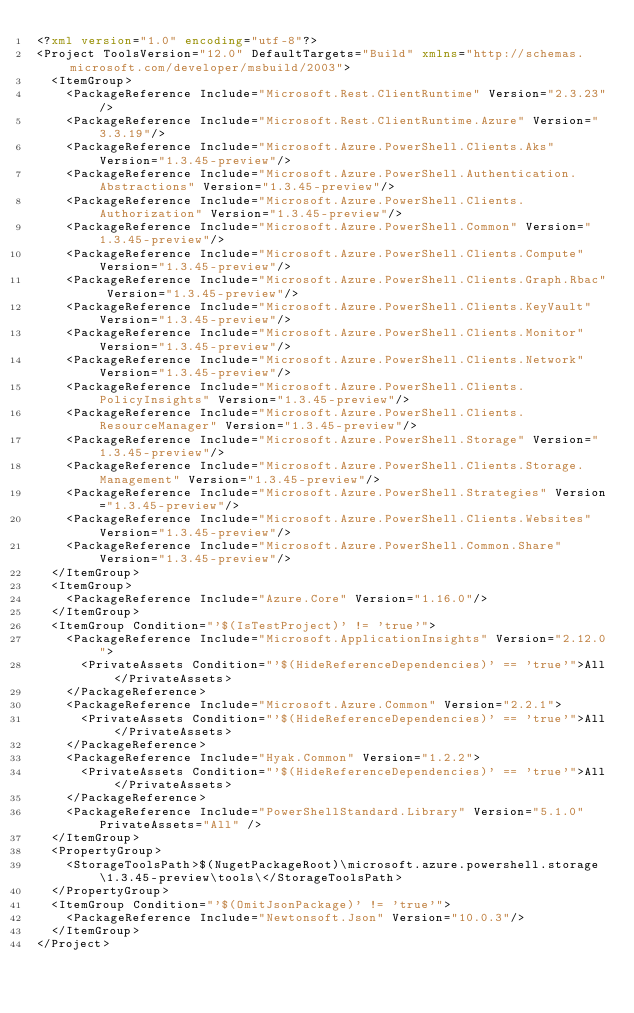Convert code to text. <code><loc_0><loc_0><loc_500><loc_500><_XML_><?xml version="1.0" encoding="utf-8"?>
<Project ToolsVersion="12.0" DefaultTargets="Build" xmlns="http://schemas.microsoft.com/developer/msbuild/2003">
  <ItemGroup>
    <PackageReference Include="Microsoft.Rest.ClientRuntime" Version="2.3.23"/>
    <PackageReference Include="Microsoft.Rest.ClientRuntime.Azure" Version="3.3.19"/>
    <PackageReference Include="Microsoft.Azure.PowerShell.Clients.Aks" Version="1.3.45-preview"/>
    <PackageReference Include="Microsoft.Azure.PowerShell.Authentication.Abstractions" Version="1.3.45-preview"/>
    <PackageReference Include="Microsoft.Azure.PowerShell.Clients.Authorization" Version="1.3.45-preview"/>
    <PackageReference Include="Microsoft.Azure.PowerShell.Common" Version="1.3.45-preview"/>
    <PackageReference Include="Microsoft.Azure.PowerShell.Clients.Compute" Version="1.3.45-preview"/>
    <PackageReference Include="Microsoft.Azure.PowerShell.Clients.Graph.Rbac" Version="1.3.45-preview"/>
    <PackageReference Include="Microsoft.Azure.PowerShell.Clients.KeyVault" Version="1.3.45-preview"/>
    <PackageReference Include="Microsoft.Azure.PowerShell.Clients.Monitor" Version="1.3.45-preview"/>
    <PackageReference Include="Microsoft.Azure.PowerShell.Clients.Network" Version="1.3.45-preview"/>
    <PackageReference Include="Microsoft.Azure.PowerShell.Clients.PolicyInsights" Version="1.3.45-preview"/>
    <PackageReference Include="Microsoft.Azure.PowerShell.Clients.ResourceManager" Version="1.3.45-preview"/>
    <PackageReference Include="Microsoft.Azure.PowerShell.Storage" Version="1.3.45-preview"/>
    <PackageReference Include="Microsoft.Azure.PowerShell.Clients.Storage.Management" Version="1.3.45-preview"/>
    <PackageReference Include="Microsoft.Azure.PowerShell.Strategies" Version="1.3.45-preview"/>
    <PackageReference Include="Microsoft.Azure.PowerShell.Clients.Websites" Version="1.3.45-preview"/>
    <PackageReference Include="Microsoft.Azure.PowerShell.Common.Share" Version="1.3.45-preview"/>
  </ItemGroup>
  <ItemGroup>
    <PackageReference Include="Azure.Core" Version="1.16.0"/>
  </ItemGroup>
  <ItemGroup Condition="'$(IsTestProject)' != 'true'">
    <PackageReference Include="Microsoft.ApplicationInsights" Version="2.12.0">
      <PrivateAssets Condition="'$(HideReferenceDependencies)' == 'true'">All</PrivateAssets>
    </PackageReference>
    <PackageReference Include="Microsoft.Azure.Common" Version="2.2.1">
      <PrivateAssets Condition="'$(HideReferenceDependencies)' == 'true'">All</PrivateAssets>
    </PackageReference>
    <PackageReference Include="Hyak.Common" Version="1.2.2">
      <PrivateAssets Condition="'$(HideReferenceDependencies)' == 'true'">All</PrivateAssets>
    </PackageReference>
    <PackageReference Include="PowerShellStandard.Library" Version="5.1.0" PrivateAssets="All" />
  </ItemGroup>
  <PropertyGroup>
    <StorageToolsPath>$(NugetPackageRoot)\microsoft.azure.powershell.storage\1.3.45-preview\tools\</StorageToolsPath>
  </PropertyGroup>
  <ItemGroup Condition="'$(OmitJsonPackage)' != 'true'">
    <PackageReference Include="Newtonsoft.Json" Version="10.0.3"/>
  </ItemGroup>
</Project>
</code> 